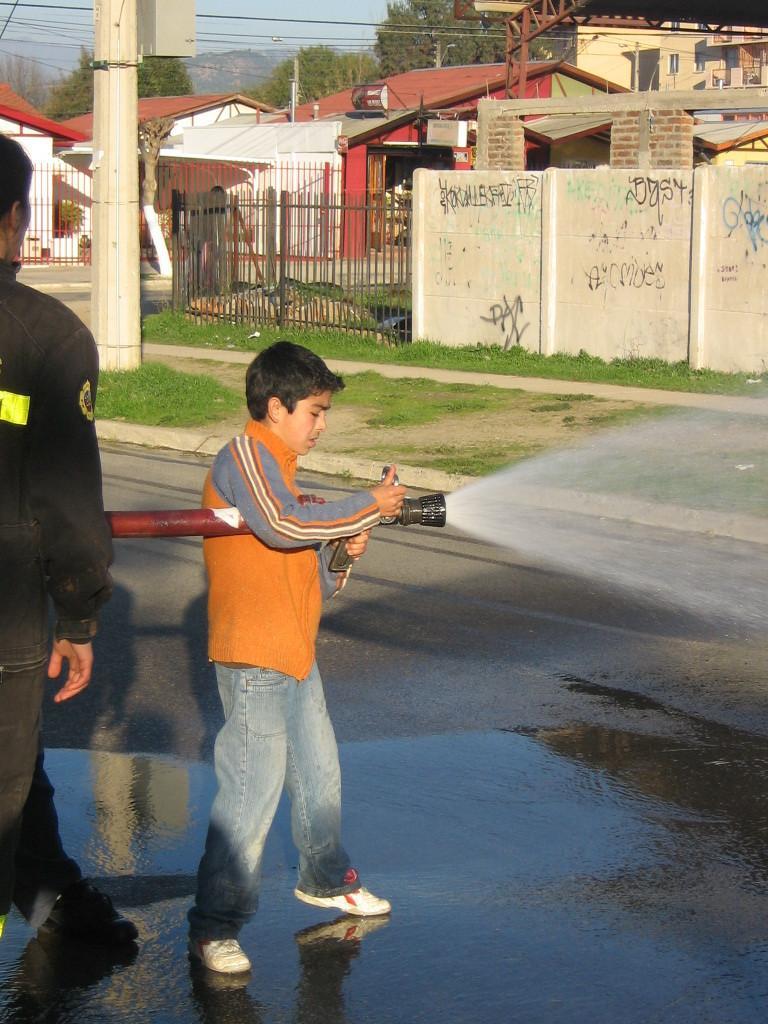In one or two sentences, can you explain what this image depicts? Here I can see a boy and a man are standing on the road. The boy is wearing an orange color jacket, jeans, white color shoes and holding camera and a pole in the hands. The man is wearing black color dress. Beside the road there is a pole placed on the footpath and also I can see the grass. In the background there are some buildings and trees. On the top of the image I can see the sky and some wires. 